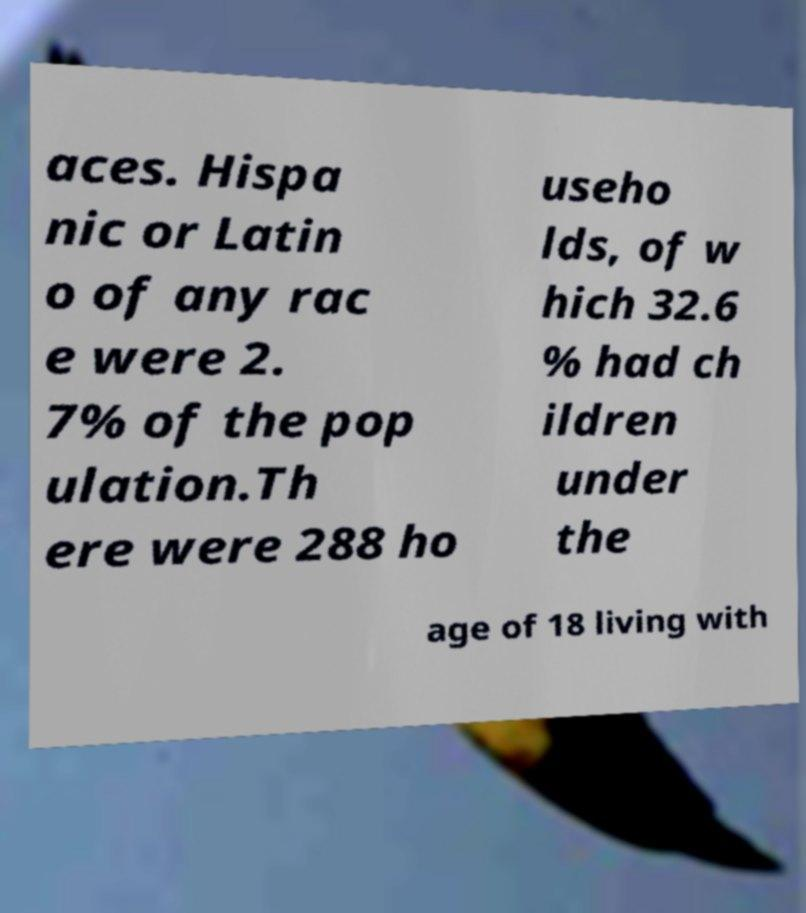Please identify and transcribe the text found in this image. aces. Hispa nic or Latin o of any rac e were 2. 7% of the pop ulation.Th ere were 288 ho useho lds, of w hich 32.6 % had ch ildren under the age of 18 living with 